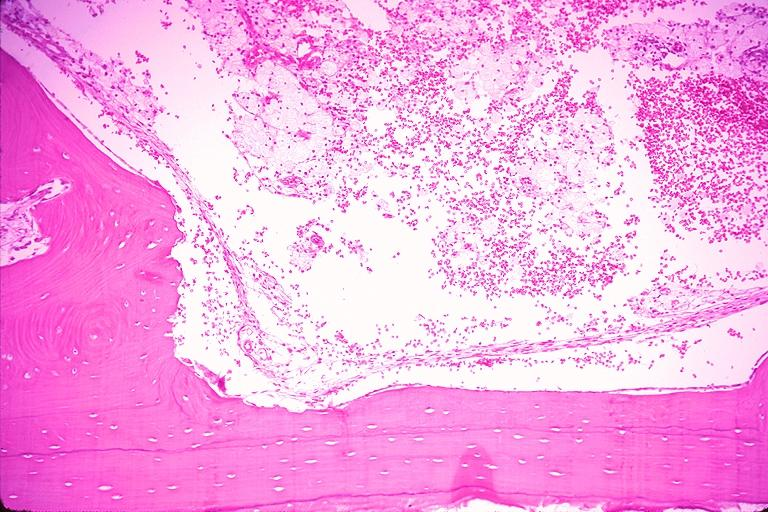does this image show traumatic bone cyst simple bone cyst?
Answer the question using a single word or phrase. Yes 